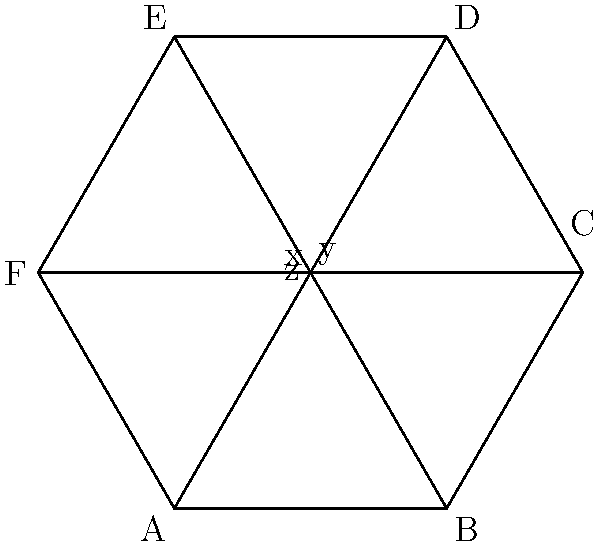As the PTA leader, you're overseeing the design of a new hexagonal playground. The playground is represented by the regular hexagon ABCDEF, with diagonals AD, BE, and CF. If the measure of angle BAF is 60°, what is the sum of the measures of angles x, y, and z formed by the intersecting diagonals? Let's approach this step-by-step:

1) In a regular hexagon, all interior angles are 120°. This is because the sum of interior angles of a hexagon is $(n-2) \times 180°$ where $n=6$, so $(6-2) \times 180° = 720°$. Dividing this by 6 gives 120° for each angle.

2) The diagonals of a regular hexagon divide it into six congruent equilateral triangles. This is because:
   - The hexagon has rotational symmetry of order 6
   - Each diagonal connects opposite vertices, passing through the center

3) In an equilateral triangle, all angles are 60°. Therefore, angle BAF, which is given as 60°, is one of these angles.

4) The three diagonals intersect at the center of the hexagon, creating six congruent central angles, each measuring 60°.

5) Angles x, y, and z are alternate angles to these central angles. In a straight line, alternate angles are equal.

6) Therefore, each of x, y, and z is also 60°.

7) The sum of x, y, and z is thus: $60° + 60° + 60° = 180°$

This result is consistent with the fact that these three angles form a triangle at the center of the hexagon, and the sum of angles in any triangle is always 180°.
Answer: 180° 